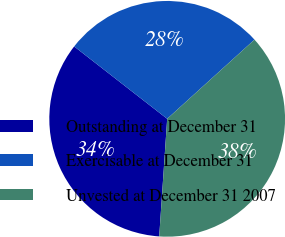Convert chart to OTSL. <chart><loc_0><loc_0><loc_500><loc_500><pie_chart><fcel>Outstanding at December 31<fcel>Exercisable at December 31<fcel>Unvested at December 31 2007<nl><fcel>34.45%<fcel>27.75%<fcel>37.8%<nl></chart> 